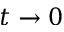<formula> <loc_0><loc_0><loc_500><loc_500>t \rightarrow 0</formula> 